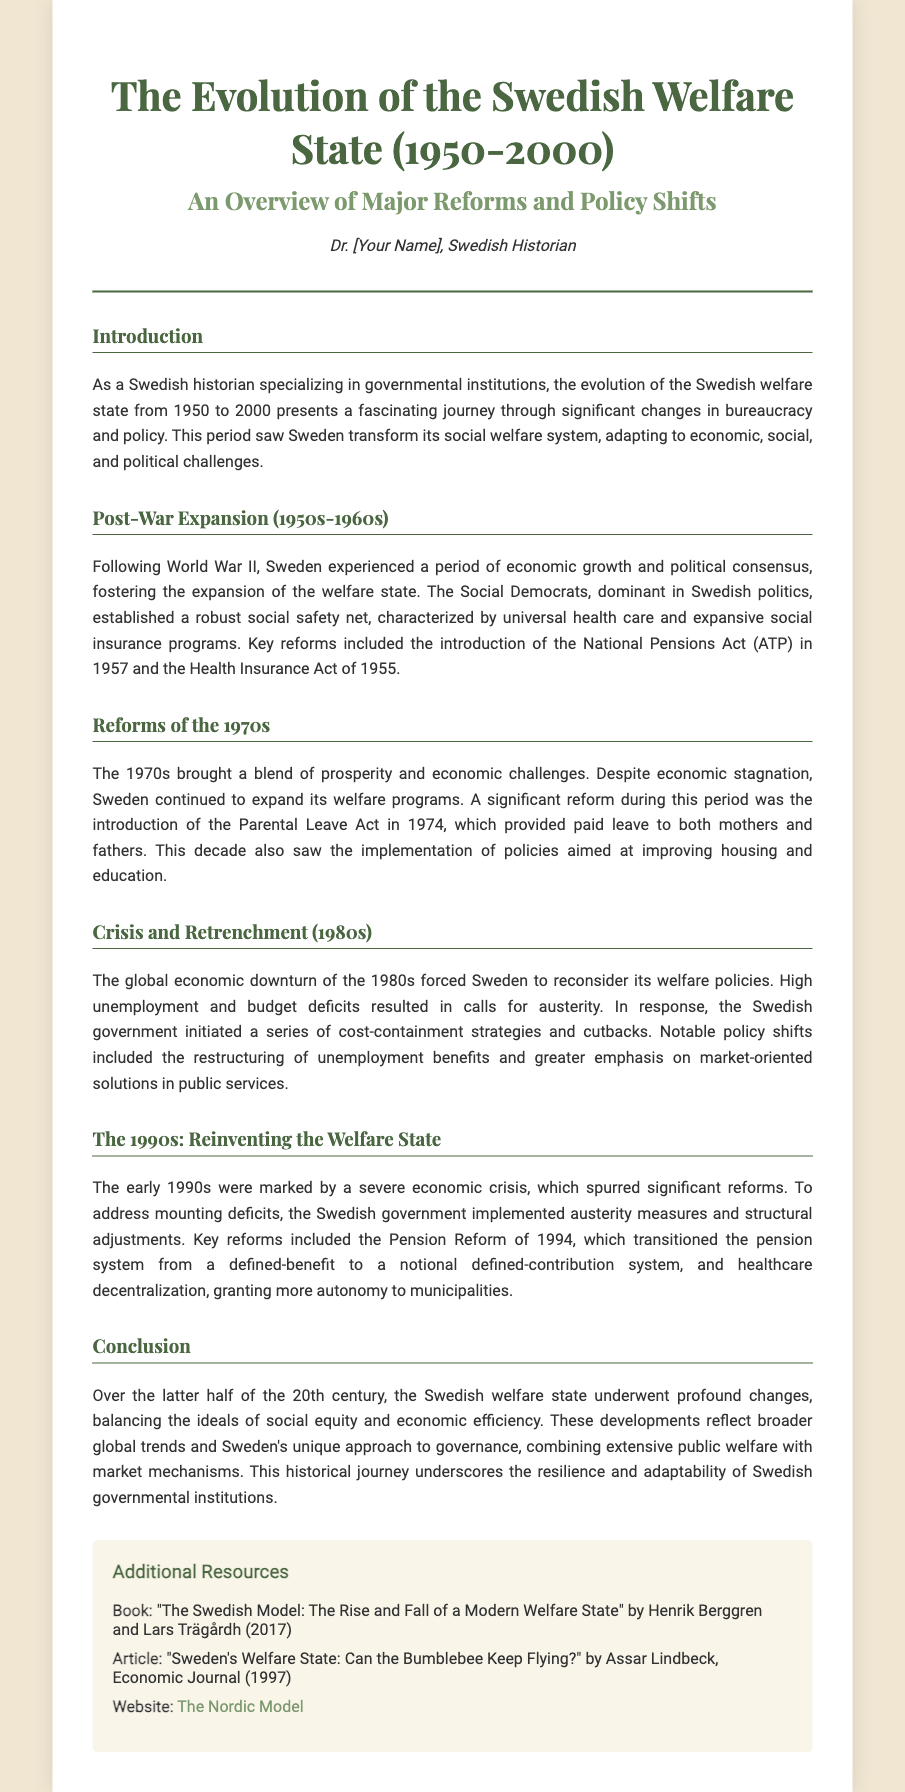What year did the National Pensions Act (ATP) get introduced? The document states that the National Pensions Act (ATP) was introduced in 1957.
Answer: 1957 What significant act was introduced in 1974? The document mentions the introduction of the Parental Leave Act in 1974 as a significant reform.
Answer: Parental Leave Act During which decade did Sweden face economic stagnation yet continued welfare expansion? The document indicates that economic stagnation occurred during the 1970s.
Answer: 1970s What major reform occurred in 1994 regarding pensions? The document states that the Pension Reform of 1994 transitioned the pension system to a notional defined-contribution system.
Answer: Pension Reform of 1994 What was a key focus of the 1980s in Sweden's welfare policy? The document describes the emphasis on cost-containment strategies and market-oriented solutions in public services during the 1980s.
Answer: Cost-containment strategies What type of changes does the conclusion of the document mention regarding the Swedish welfare state? The conclusion mentions profound changes balancing social equity and economic efficiency.
Answer: Profound changes What did the author of the document specialize in? The document states that the author specializes in governmental institutions.
Answer: Governmental institutions What is the title of the book recommended in the additional resources? The document lists "The Swedish Model: The Rise and Fall of a Modern Welfare State" as a recommended book.
Answer: The Swedish Model: The Rise and Fall of a Modern Welfare State 